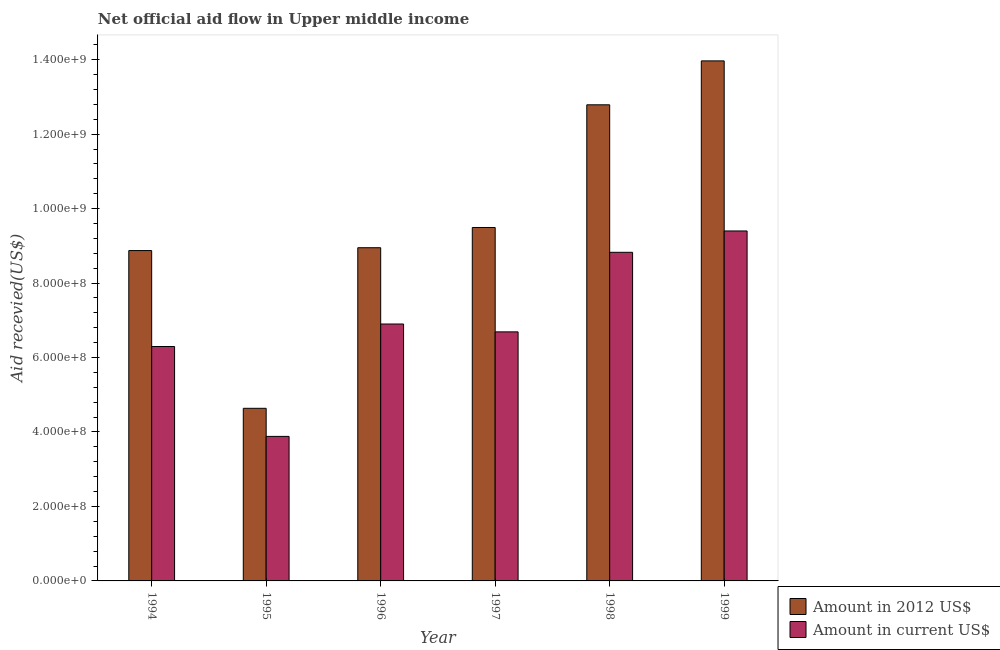How many bars are there on the 6th tick from the left?
Provide a short and direct response. 2. What is the label of the 1st group of bars from the left?
Provide a short and direct response. 1994. What is the amount of aid received(expressed in 2012 us$) in 1995?
Your answer should be very brief. 4.64e+08. Across all years, what is the maximum amount of aid received(expressed in 2012 us$)?
Provide a succinct answer. 1.40e+09. Across all years, what is the minimum amount of aid received(expressed in 2012 us$)?
Offer a very short reply. 4.64e+08. What is the total amount of aid received(expressed in 2012 us$) in the graph?
Provide a short and direct response. 5.87e+09. What is the difference between the amount of aid received(expressed in 2012 us$) in 1995 and that in 1999?
Offer a very short reply. -9.33e+08. What is the difference between the amount of aid received(expressed in 2012 us$) in 1995 and the amount of aid received(expressed in us$) in 1998?
Provide a succinct answer. -8.15e+08. What is the average amount of aid received(expressed in 2012 us$) per year?
Keep it short and to the point. 9.78e+08. In the year 1995, what is the difference between the amount of aid received(expressed in 2012 us$) and amount of aid received(expressed in us$)?
Make the answer very short. 0. What is the ratio of the amount of aid received(expressed in us$) in 1997 to that in 1999?
Give a very brief answer. 0.71. Is the amount of aid received(expressed in us$) in 1994 less than that in 1997?
Give a very brief answer. Yes. What is the difference between the highest and the second highest amount of aid received(expressed in us$)?
Offer a very short reply. 5.73e+07. What is the difference between the highest and the lowest amount of aid received(expressed in us$)?
Offer a terse response. 5.52e+08. Is the sum of the amount of aid received(expressed in 2012 us$) in 1996 and 1999 greater than the maximum amount of aid received(expressed in us$) across all years?
Provide a short and direct response. Yes. What does the 1st bar from the left in 1998 represents?
Make the answer very short. Amount in 2012 US$. What does the 2nd bar from the right in 1995 represents?
Provide a succinct answer. Amount in 2012 US$. How many bars are there?
Your answer should be compact. 12. How many years are there in the graph?
Keep it short and to the point. 6. What is the difference between two consecutive major ticks on the Y-axis?
Ensure brevity in your answer.  2.00e+08. Does the graph contain any zero values?
Keep it short and to the point. No. How many legend labels are there?
Offer a terse response. 2. How are the legend labels stacked?
Provide a short and direct response. Vertical. What is the title of the graph?
Offer a terse response. Net official aid flow in Upper middle income. What is the label or title of the X-axis?
Your answer should be very brief. Year. What is the label or title of the Y-axis?
Your answer should be compact. Aid recevied(US$). What is the Aid recevied(US$) of Amount in 2012 US$ in 1994?
Provide a succinct answer. 8.87e+08. What is the Aid recevied(US$) of Amount in current US$ in 1994?
Keep it short and to the point. 6.30e+08. What is the Aid recevied(US$) in Amount in 2012 US$ in 1995?
Make the answer very short. 4.64e+08. What is the Aid recevied(US$) in Amount in current US$ in 1995?
Keep it short and to the point. 3.88e+08. What is the Aid recevied(US$) in Amount in 2012 US$ in 1996?
Offer a very short reply. 8.95e+08. What is the Aid recevied(US$) of Amount in current US$ in 1996?
Keep it short and to the point. 6.90e+08. What is the Aid recevied(US$) of Amount in 2012 US$ in 1997?
Provide a short and direct response. 9.49e+08. What is the Aid recevied(US$) in Amount in current US$ in 1997?
Make the answer very short. 6.69e+08. What is the Aid recevied(US$) in Amount in 2012 US$ in 1998?
Provide a succinct answer. 1.28e+09. What is the Aid recevied(US$) of Amount in current US$ in 1998?
Keep it short and to the point. 8.83e+08. What is the Aid recevied(US$) in Amount in 2012 US$ in 1999?
Keep it short and to the point. 1.40e+09. What is the Aid recevied(US$) of Amount in current US$ in 1999?
Provide a succinct answer. 9.40e+08. Across all years, what is the maximum Aid recevied(US$) of Amount in 2012 US$?
Keep it short and to the point. 1.40e+09. Across all years, what is the maximum Aid recevied(US$) of Amount in current US$?
Provide a succinct answer. 9.40e+08. Across all years, what is the minimum Aid recevied(US$) of Amount in 2012 US$?
Give a very brief answer. 4.64e+08. Across all years, what is the minimum Aid recevied(US$) of Amount in current US$?
Your answer should be very brief. 3.88e+08. What is the total Aid recevied(US$) in Amount in 2012 US$ in the graph?
Provide a short and direct response. 5.87e+09. What is the total Aid recevied(US$) of Amount in current US$ in the graph?
Offer a terse response. 4.20e+09. What is the difference between the Aid recevied(US$) of Amount in 2012 US$ in 1994 and that in 1995?
Provide a succinct answer. 4.24e+08. What is the difference between the Aid recevied(US$) of Amount in current US$ in 1994 and that in 1995?
Keep it short and to the point. 2.41e+08. What is the difference between the Aid recevied(US$) in Amount in 2012 US$ in 1994 and that in 1996?
Provide a succinct answer. -7.65e+06. What is the difference between the Aid recevied(US$) of Amount in current US$ in 1994 and that in 1996?
Keep it short and to the point. -6.04e+07. What is the difference between the Aid recevied(US$) of Amount in 2012 US$ in 1994 and that in 1997?
Give a very brief answer. -6.20e+07. What is the difference between the Aid recevied(US$) in Amount in current US$ in 1994 and that in 1997?
Offer a very short reply. -3.93e+07. What is the difference between the Aid recevied(US$) in Amount in 2012 US$ in 1994 and that in 1998?
Keep it short and to the point. -3.92e+08. What is the difference between the Aid recevied(US$) in Amount in current US$ in 1994 and that in 1998?
Your answer should be very brief. -2.53e+08. What is the difference between the Aid recevied(US$) in Amount in 2012 US$ in 1994 and that in 1999?
Give a very brief answer. -5.10e+08. What is the difference between the Aid recevied(US$) of Amount in current US$ in 1994 and that in 1999?
Provide a short and direct response. -3.10e+08. What is the difference between the Aid recevied(US$) in Amount in 2012 US$ in 1995 and that in 1996?
Make the answer very short. -4.31e+08. What is the difference between the Aid recevied(US$) in Amount in current US$ in 1995 and that in 1996?
Ensure brevity in your answer.  -3.02e+08. What is the difference between the Aid recevied(US$) in Amount in 2012 US$ in 1995 and that in 1997?
Your answer should be compact. -4.86e+08. What is the difference between the Aid recevied(US$) in Amount in current US$ in 1995 and that in 1997?
Keep it short and to the point. -2.81e+08. What is the difference between the Aid recevied(US$) in Amount in 2012 US$ in 1995 and that in 1998?
Your answer should be compact. -8.15e+08. What is the difference between the Aid recevied(US$) in Amount in current US$ in 1995 and that in 1998?
Provide a succinct answer. -4.94e+08. What is the difference between the Aid recevied(US$) in Amount in 2012 US$ in 1995 and that in 1999?
Make the answer very short. -9.33e+08. What is the difference between the Aid recevied(US$) of Amount in current US$ in 1995 and that in 1999?
Offer a terse response. -5.52e+08. What is the difference between the Aid recevied(US$) of Amount in 2012 US$ in 1996 and that in 1997?
Your answer should be very brief. -5.43e+07. What is the difference between the Aid recevied(US$) in Amount in current US$ in 1996 and that in 1997?
Give a very brief answer. 2.11e+07. What is the difference between the Aid recevied(US$) in Amount in 2012 US$ in 1996 and that in 1998?
Your answer should be very brief. -3.84e+08. What is the difference between the Aid recevied(US$) in Amount in current US$ in 1996 and that in 1998?
Your response must be concise. -1.93e+08. What is the difference between the Aid recevied(US$) of Amount in 2012 US$ in 1996 and that in 1999?
Offer a terse response. -5.02e+08. What is the difference between the Aid recevied(US$) of Amount in current US$ in 1996 and that in 1999?
Keep it short and to the point. -2.50e+08. What is the difference between the Aid recevied(US$) of Amount in 2012 US$ in 1997 and that in 1998?
Ensure brevity in your answer.  -3.30e+08. What is the difference between the Aid recevied(US$) of Amount in current US$ in 1997 and that in 1998?
Offer a very short reply. -2.14e+08. What is the difference between the Aid recevied(US$) of Amount in 2012 US$ in 1997 and that in 1999?
Keep it short and to the point. -4.48e+08. What is the difference between the Aid recevied(US$) in Amount in current US$ in 1997 and that in 1999?
Offer a very short reply. -2.71e+08. What is the difference between the Aid recevied(US$) of Amount in 2012 US$ in 1998 and that in 1999?
Give a very brief answer. -1.18e+08. What is the difference between the Aid recevied(US$) in Amount in current US$ in 1998 and that in 1999?
Give a very brief answer. -5.73e+07. What is the difference between the Aid recevied(US$) in Amount in 2012 US$ in 1994 and the Aid recevied(US$) in Amount in current US$ in 1995?
Give a very brief answer. 4.99e+08. What is the difference between the Aid recevied(US$) in Amount in 2012 US$ in 1994 and the Aid recevied(US$) in Amount in current US$ in 1996?
Provide a short and direct response. 1.97e+08. What is the difference between the Aid recevied(US$) of Amount in 2012 US$ in 1994 and the Aid recevied(US$) of Amount in current US$ in 1997?
Provide a succinct answer. 2.18e+08. What is the difference between the Aid recevied(US$) of Amount in 2012 US$ in 1994 and the Aid recevied(US$) of Amount in current US$ in 1998?
Provide a succinct answer. 4.66e+06. What is the difference between the Aid recevied(US$) in Amount in 2012 US$ in 1994 and the Aid recevied(US$) in Amount in current US$ in 1999?
Offer a very short reply. -5.27e+07. What is the difference between the Aid recevied(US$) of Amount in 2012 US$ in 1995 and the Aid recevied(US$) of Amount in current US$ in 1996?
Ensure brevity in your answer.  -2.26e+08. What is the difference between the Aid recevied(US$) in Amount in 2012 US$ in 1995 and the Aid recevied(US$) in Amount in current US$ in 1997?
Ensure brevity in your answer.  -2.05e+08. What is the difference between the Aid recevied(US$) in Amount in 2012 US$ in 1995 and the Aid recevied(US$) in Amount in current US$ in 1998?
Offer a terse response. -4.19e+08. What is the difference between the Aid recevied(US$) in Amount in 2012 US$ in 1995 and the Aid recevied(US$) in Amount in current US$ in 1999?
Your answer should be very brief. -4.76e+08. What is the difference between the Aid recevied(US$) of Amount in 2012 US$ in 1996 and the Aid recevied(US$) of Amount in current US$ in 1997?
Ensure brevity in your answer.  2.26e+08. What is the difference between the Aid recevied(US$) in Amount in 2012 US$ in 1996 and the Aid recevied(US$) in Amount in current US$ in 1998?
Offer a terse response. 1.23e+07. What is the difference between the Aid recevied(US$) of Amount in 2012 US$ in 1996 and the Aid recevied(US$) of Amount in current US$ in 1999?
Provide a succinct answer. -4.50e+07. What is the difference between the Aid recevied(US$) of Amount in 2012 US$ in 1997 and the Aid recevied(US$) of Amount in current US$ in 1998?
Your response must be concise. 6.66e+07. What is the difference between the Aid recevied(US$) in Amount in 2012 US$ in 1997 and the Aid recevied(US$) in Amount in current US$ in 1999?
Offer a very short reply. 9.30e+06. What is the difference between the Aid recevied(US$) of Amount in 2012 US$ in 1998 and the Aid recevied(US$) of Amount in current US$ in 1999?
Ensure brevity in your answer.  3.39e+08. What is the average Aid recevied(US$) in Amount in 2012 US$ per year?
Provide a short and direct response. 9.78e+08. What is the average Aid recevied(US$) of Amount in current US$ per year?
Provide a succinct answer. 7.00e+08. In the year 1994, what is the difference between the Aid recevied(US$) in Amount in 2012 US$ and Aid recevied(US$) in Amount in current US$?
Make the answer very short. 2.58e+08. In the year 1995, what is the difference between the Aid recevied(US$) in Amount in 2012 US$ and Aid recevied(US$) in Amount in current US$?
Provide a short and direct response. 7.54e+07. In the year 1996, what is the difference between the Aid recevied(US$) of Amount in 2012 US$ and Aid recevied(US$) of Amount in current US$?
Provide a short and direct response. 2.05e+08. In the year 1997, what is the difference between the Aid recevied(US$) in Amount in 2012 US$ and Aid recevied(US$) in Amount in current US$?
Offer a terse response. 2.80e+08. In the year 1998, what is the difference between the Aid recevied(US$) of Amount in 2012 US$ and Aid recevied(US$) of Amount in current US$?
Ensure brevity in your answer.  3.96e+08. In the year 1999, what is the difference between the Aid recevied(US$) in Amount in 2012 US$ and Aid recevied(US$) in Amount in current US$?
Offer a terse response. 4.57e+08. What is the ratio of the Aid recevied(US$) in Amount in 2012 US$ in 1994 to that in 1995?
Your response must be concise. 1.91. What is the ratio of the Aid recevied(US$) in Amount in current US$ in 1994 to that in 1995?
Your response must be concise. 1.62. What is the ratio of the Aid recevied(US$) in Amount in current US$ in 1994 to that in 1996?
Ensure brevity in your answer.  0.91. What is the ratio of the Aid recevied(US$) in Amount in 2012 US$ in 1994 to that in 1997?
Keep it short and to the point. 0.93. What is the ratio of the Aid recevied(US$) in Amount in current US$ in 1994 to that in 1997?
Provide a short and direct response. 0.94. What is the ratio of the Aid recevied(US$) of Amount in 2012 US$ in 1994 to that in 1998?
Provide a succinct answer. 0.69. What is the ratio of the Aid recevied(US$) in Amount in current US$ in 1994 to that in 1998?
Your answer should be compact. 0.71. What is the ratio of the Aid recevied(US$) of Amount in 2012 US$ in 1994 to that in 1999?
Your answer should be compact. 0.64. What is the ratio of the Aid recevied(US$) of Amount in current US$ in 1994 to that in 1999?
Provide a short and direct response. 0.67. What is the ratio of the Aid recevied(US$) in Amount in 2012 US$ in 1995 to that in 1996?
Make the answer very short. 0.52. What is the ratio of the Aid recevied(US$) of Amount in current US$ in 1995 to that in 1996?
Give a very brief answer. 0.56. What is the ratio of the Aid recevied(US$) of Amount in 2012 US$ in 1995 to that in 1997?
Your answer should be very brief. 0.49. What is the ratio of the Aid recevied(US$) in Amount in current US$ in 1995 to that in 1997?
Keep it short and to the point. 0.58. What is the ratio of the Aid recevied(US$) in Amount in 2012 US$ in 1995 to that in 1998?
Your response must be concise. 0.36. What is the ratio of the Aid recevied(US$) of Amount in current US$ in 1995 to that in 1998?
Provide a succinct answer. 0.44. What is the ratio of the Aid recevied(US$) in Amount in 2012 US$ in 1995 to that in 1999?
Make the answer very short. 0.33. What is the ratio of the Aid recevied(US$) in Amount in current US$ in 1995 to that in 1999?
Your response must be concise. 0.41. What is the ratio of the Aid recevied(US$) of Amount in 2012 US$ in 1996 to that in 1997?
Give a very brief answer. 0.94. What is the ratio of the Aid recevied(US$) of Amount in current US$ in 1996 to that in 1997?
Your response must be concise. 1.03. What is the ratio of the Aid recevied(US$) in Amount in 2012 US$ in 1996 to that in 1998?
Ensure brevity in your answer.  0.7. What is the ratio of the Aid recevied(US$) in Amount in current US$ in 1996 to that in 1998?
Provide a succinct answer. 0.78. What is the ratio of the Aid recevied(US$) in Amount in 2012 US$ in 1996 to that in 1999?
Your answer should be very brief. 0.64. What is the ratio of the Aid recevied(US$) in Amount in current US$ in 1996 to that in 1999?
Keep it short and to the point. 0.73. What is the ratio of the Aid recevied(US$) in Amount in 2012 US$ in 1997 to that in 1998?
Offer a terse response. 0.74. What is the ratio of the Aid recevied(US$) of Amount in current US$ in 1997 to that in 1998?
Your answer should be very brief. 0.76. What is the ratio of the Aid recevied(US$) of Amount in 2012 US$ in 1997 to that in 1999?
Your answer should be very brief. 0.68. What is the ratio of the Aid recevied(US$) in Amount in current US$ in 1997 to that in 1999?
Your response must be concise. 0.71. What is the ratio of the Aid recevied(US$) of Amount in 2012 US$ in 1998 to that in 1999?
Offer a very short reply. 0.92. What is the ratio of the Aid recevied(US$) of Amount in current US$ in 1998 to that in 1999?
Provide a succinct answer. 0.94. What is the difference between the highest and the second highest Aid recevied(US$) in Amount in 2012 US$?
Your answer should be very brief. 1.18e+08. What is the difference between the highest and the second highest Aid recevied(US$) of Amount in current US$?
Keep it short and to the point. 5.73e+07. What is the difference between the highest and the lowest Aid recevied(US$) in Amount in 2012 US$?
Make the answer very short. 9.33e+08. What is the difference between the highest and the lowest Aid recevied(US$) in Amount in current US$?
Offer a terse response. 5.52e+08. 